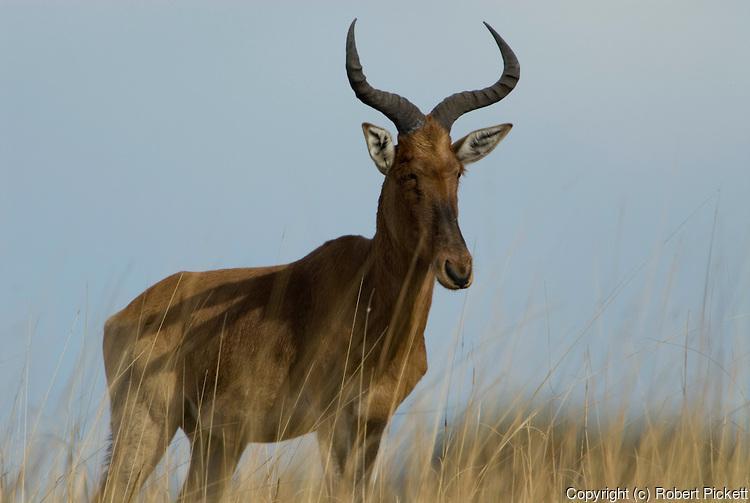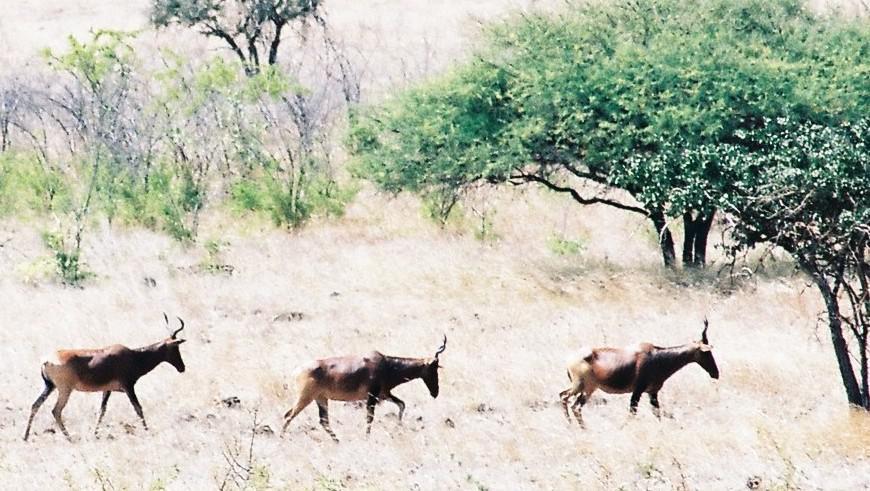The first image is the image on the left, the second image is the image on the right. Examine the images to the left and right. Is the description "there are no more than three animals in the image on the right" accurate? Answer yes or no. Yes. 